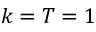<formula> <loc_0><loc_0><loc_500><loc_500>k = T = 1</formula> 